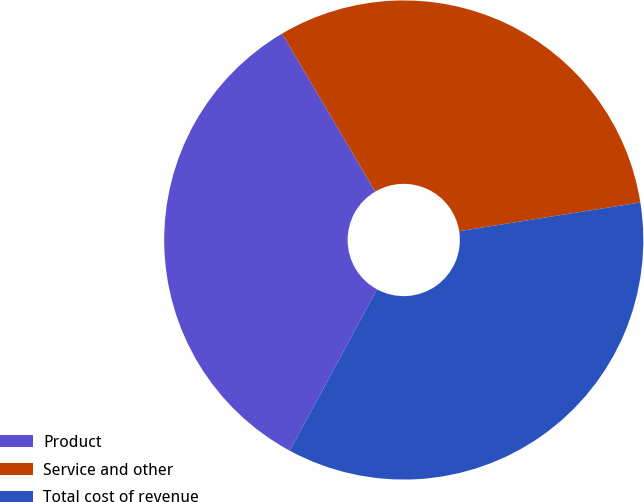Convert chart to OTSL. <chart><loc_0><loc_0><loc_500><loc_500><pie_chart><fcel>Product<fcel>Service and other<fcel>Total cost of revenue<nl><fcel>33.63%<fcel>30.97%<fcel>35.4%<nl></chart> 